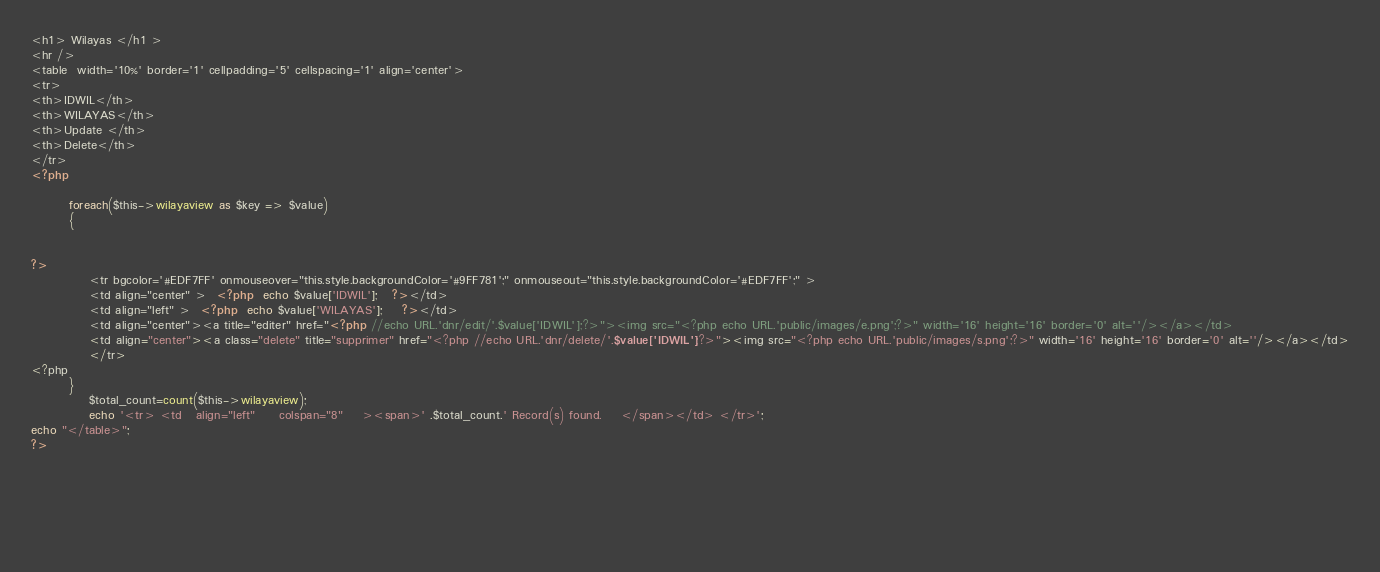<code> <loc_0><loc_0><loc_500><loc_500><_PHP_><h1> Wilayas </h1 >
<hr />
<table  width='10%' border='1' cellpadding='5' cellspacing='1' align='center'>
<tr>
<th>IDWIL</th>
<th>WILAYAS</th>
<th>Update </th>
<th>Delete</th>
</tr>
<?php				

		foreach($this->wilayaview as $key => $value)
		{ 
		
		
?>
			<tr bgcolor='#EDF7FF' onmouseover="this.style.backgroundColor='#9FF781';" onmouseout="this.style.backgroundColor='#EDF7FF';" >
			<td align="center" >  <?php  echo $value['IDWIL'];   ?></td>
			<td align="left" >  <?php  echo $value['WILAYAS'];    ?></td>
			<td align="center"><a title="editer" href="<?php //echo URL.'dnr/edit/'.$value['IDWIL'];?>"><img src="<?php echo URL.'public/images/e.png';?>" width='16' height='16' border='0' alt=''/></a></td>
			<td align="center"><a class="delete" title="supprimer" href="<?php //echo URL.'dnr/delete/'.$value['IDWIL'];?>"><img src="<?php echo URL.'public/images/s.png';?>" width='16' height='16' border='0' alt=''/></a></td>
			</tr>
<?php 
		}
            $total_count=count($this->wilayaview);		
		    echo '<tr> <td   align="left"     colspan="8"    ><span>' .$total_count.' Record(s) found.    </span></td> </tr>';							
echo "</table>";	
?>



 
 
 
</code> 